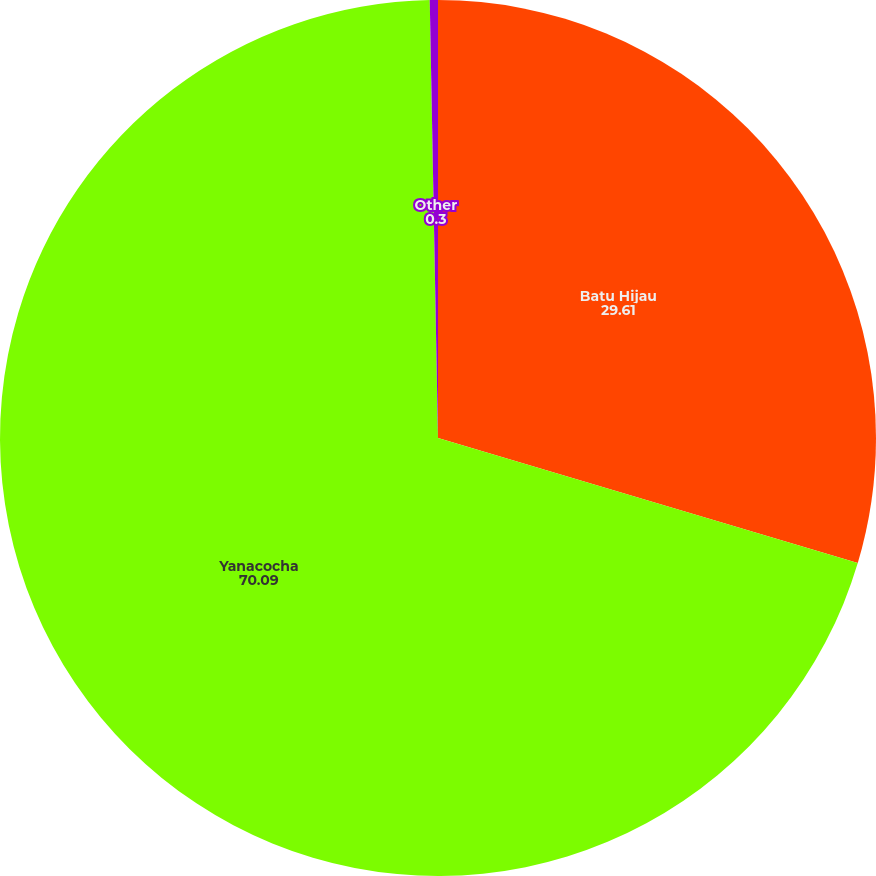<chart> <loc_0><loc_0><loc_500><loc_500><pie_chart><fcel>Batu Hijau<fcel>Yanacocha<fcel>Other<nl><fcel>29.61%<fcel>70.09%<fcel>0.3%<nl></chart> 